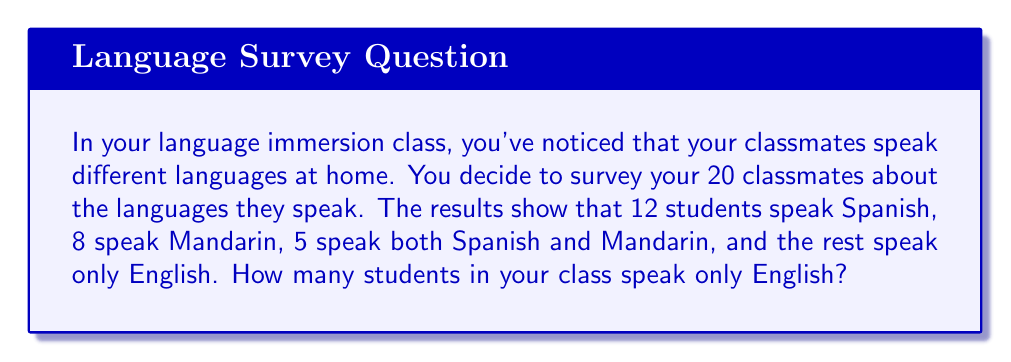What is the answer to this math problem? Let's approach this step-by-step using set theory:

1) Let's define our sets:
   $S$ = students who speak Spanish
   $M$ = students who speak Mandarin
   $E$ = students who speak only English

2) We know:
   $|S| = 12$ (number of students who speak Spanish)
   $|M| = 8$ (number of students who speak Mandarin)
   $|S \cap M| = 5$ (number of students who speak both Spanish and Mandarin)
   Total number of students = 20

3) We need to find $|E|$. We can do this by subtracting the number of students who speak Spanish or Mandarin (or both) from the total number of students.

4) To find the number of students who speak Spanish or Mandarin (or both), we use the inclusion-exclusion principle:
   $|S \cup M| = |S| + |M| - |S \cap M|$
   $|S \cup M| = 12 + 8 - 5 = 15$

5) Now we can find $|E|$:
   $|E| = \text{Total students} - |S \cup M|$
   $|E| = 20 - 15 = 5$

Therefore, 5 students in the class speak only English.
Answer: 5 students 